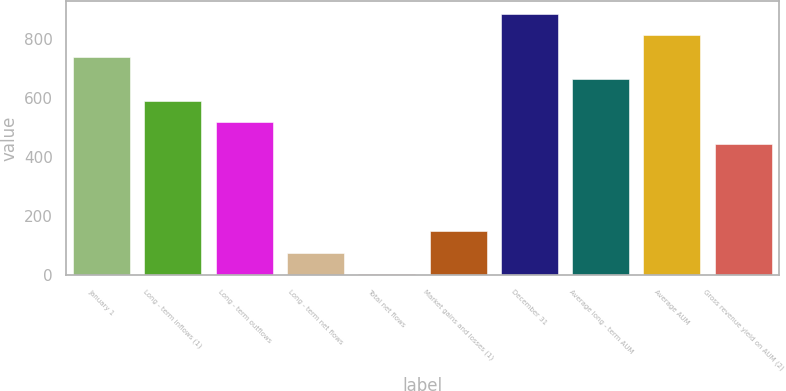Convert chart to OTSL. <chart><loc_0><loc_0><loc_500><loc_500><bar_chart><fcel>January 1<fcel>Long - term inflows (1)<fcel>Long - term outflows<fcel>Long - term net flows<fcel>Total net flows<fcel>Market gains and losses (1)<fcel>December 31<fcel>Average long - term AUM<fcel>Average AUM<fcel>Gross revenue yield on AUM (2)<nl><fcel>738.6<fcel>591.6<fcel>518.1<fcel>77.1<fcel>3.6<fcel>150.6<fcel>885.6<fcel>665.1<fcel>812.1<fcel>444.6<nl></chart> 